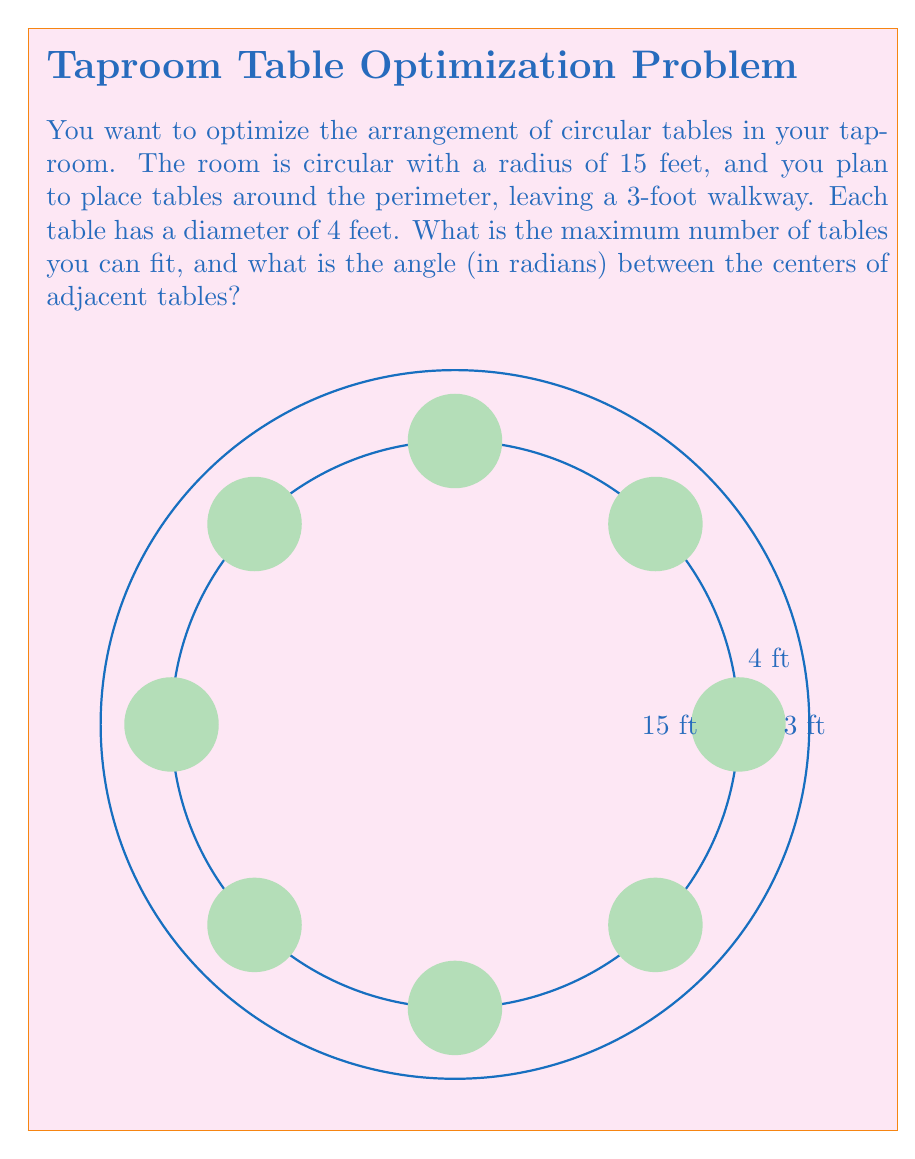Can you solve this math problem? Let's approach this step-by-step:

1) The tables will be placed in a circle with radius 12 feet (15 ft room radius - 3 ft walkway).

2) The circumference of this circle is:
   $$C = 2\pi r = 2\pi(12) = 24\pi \approx 75.4 \text{ feet}$$

3) Each table occupies 4 feet of this circumference. To find the maximum number of tables, we divide the circumference by 4 and round down:
   $$\text{Number of tables} = \lfloor \frac{24\pi}{4} \rfloor = \lfloor 6\pi \rfloor = 18$$

4) To find the angle between table centers, we divide the full circle (2π radians) by the number of tables:
   $$\text{Angle} = \frac{2\pi}{18} = \frac{\pi}{9} \approx 0.3491 \text{ radians}$$

5) We can verify this by calculating the arc length between tables:
   $$\text{Arc length} = r\theta = 12 \cdot \frac{\pi}{9} = \frac{4\pi}{3} \approx 4.19 \text{ feet}$$
   This is slightly larger than the table diameter, confirming our calculation.
Answer: 18 tables; $\frac{\pi}{9}$ radians 